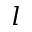<formula> <loc_0><loc_0><loc_500><loc_500>l</formula> 